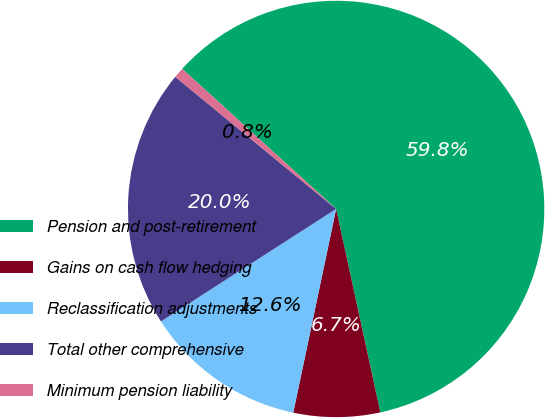Convert chart. <chart><loc_0><loc_0><loc_500><loc_500><pie_chart><fcel>Pension and post-retirement<fcel>Gains on cash flow hedging<fcel>Reclassification adjustments<fcel>Total other comprehensive<fcel>Minimum pension liability<nl><fcel>59.84%<fcel>6.71%<fcel>12.61%<fcel>20.03%<fcel>0.81%<nl></chart> 